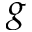Convert formula to latex. <formula><loc_0><loc_0><loc_500><loc_500>g</formula> 